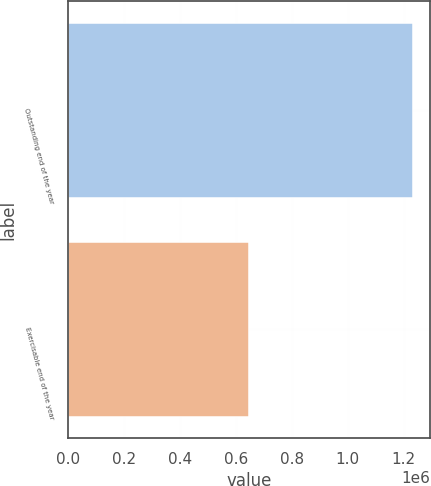<chart> <loc_0><loc_0><loc_500><loc_500><bar_chart><fcel>Outstanding end of the year<fcel>Exercisable end of the year<nl><fcel>1.23367e+06<fcel>647425<nl></chart> 